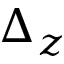Convert formula to latex. <formula><loc_0><loc_0><loc_500><loc_500>\Delta _ { z }</formula> 